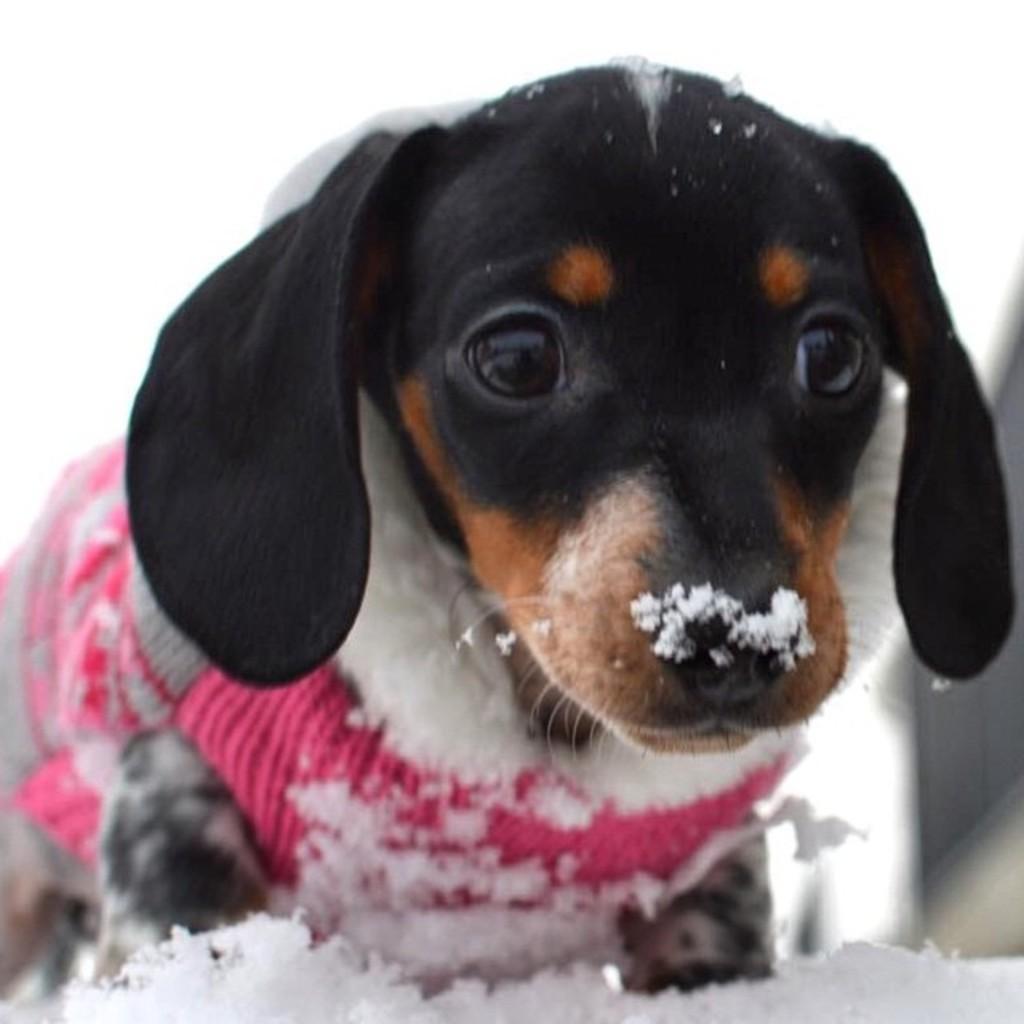Can you describe this image briefly? In this picture I can see a dog with a dress, there is snow, and there is blur background. 